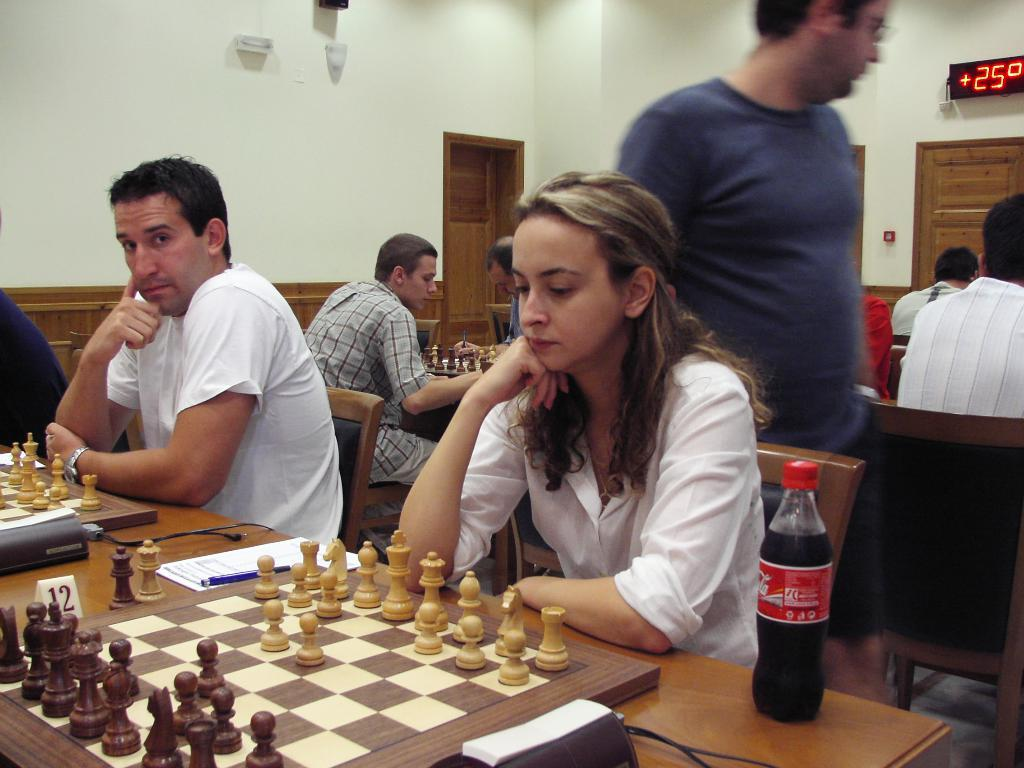What are the people in the image doing? The people in the image are playing chess. What object is being used for the game? There is a chess board in the image. Is there any other object related to the game? Yes, there is a coke bottle in the image. What is the position of the man in the image? There is a man standing and watching the people play chess. What type of canvas is being used to paint a portrait of the jail in the image? There is no canvas or jail present in the image; it features people playing chess and a man watching them. What other game is being played in the image besides chess? There is no other game being played in the image; only chess is visible. 